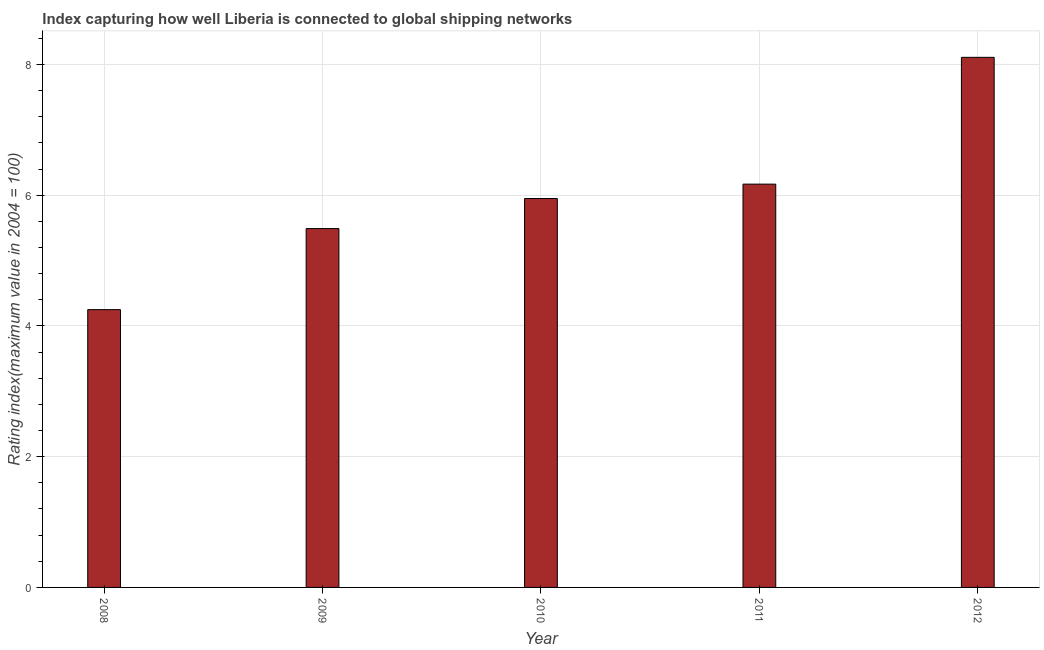Does the graph contain any zero values?
Make the answer very short. No. What is the title of the graph?
Provide a succinct answer. Index capturing how well Liberia is connected to global shipping networks. What is the label or title of the Y-axis?
Offer a very short reply. Rating index(maximum value in 2004 = 100). What is the liner shipping connectivity index in 2011?
Provide a succinct answer. 6.17. Across all years, what is the maximum liner shipping connectivity index?
Your answer should be very brief. 8.11. Across all years, what is the minimum liner shipping connectivity index?
Your answer should be compact. 4.25. In which year was the liner shipping connectivity index minimum?
Your answer should be very brief. 2008. What is the sum of the liner shipping connectivity index?
Give a very brief answer. 29.97. What is the difference between the liner shipping connectivity index in 2010 and 2012?
Provide a short and direct response. -2.16. What is the average liner shipping connectivity index per year?
Offer a very short reply. 5.99. What is the median liner shipping connectivity index?
Give a very brief answer. 5.95. Do a majority of the years between 2009 and 2011 (inclusive) have liner shipping connectivity index greater than 1.6 ?
Provide a succinct answer. Yes. What is the ratio of the liner shipping connectivity index in 2009 to that in 2011?
Make the answer very short. 0.89. Is the liner shipping connectivity index in 2010 less than that in 2011?
Your answer should be compact. Yes. Is the difference between the liner shipping connectivity index in 2008 and 2010 greater than the difference between any two years?
Your response must be concise. No. What is the difference between the highest and the second highest liner shipping connectivity index?
Provide a short and direct response. 1.94. Is the sum of the liner shipping connectivity index in 2008 and 2010 greater than the maximum liner shipping connectivity index across all years?
Offer a very short reply. Yes. What is the difference between the highest and the lowest liner shipping connectivity index?
Give a very brief answer. 3.86. In how many years, is the liner shipping connectivity index greater than the average liner shipping connectivity index taken over all years?
Give a very brief answer. 2. How many years are there in the graph?
Your answer should be compact. 5. What is the Rating index(maximum value in 2004 = 100) of 2008?
Your answer should be compact. 4.25. What is the Rating index(maximum value in 2004 = 100) in 2009?
Give a very brief answer. 5.49. What is the Rating index(maximum value in 2004 = 100) in 2010?
Your response must be concise. 5.95. What is the Rating index(maximum value in 2004 = 100) in 2011?
Offer a terse response. 6.17. What is the Rating index(maximum value in 2004 = 100) of 2012?
Keep it short and to the point. 8.11. What is the difference between the Rating index(maximum value in 2004 = 100) in 2008 and 2009?
Offer a terse response. -1.24. What is the difference between the Rating index(maximum value in 2004 = 100) in 2008 and 2011?
Offer a terse response. -1.92. What is the difference between the Rating index(maximum value in 2004 = 100) in 2008 and 2012?
Ensure brevity in your answer.  -3.86. What is the difference between the Rating index(maximum value in 2004 = 100) in 2009 and 2010?
Your response must be concise. -0.46. What is the difference between the Rating index(maximum value in 2004 = 100) in 2009 and 2011?
Ensure brevity in your answer.  -0.68. What is the difference between the Rating index(maximum value in 2004 = 100) in 2009 and 2012?
Your answer should be compact. -2.62. What is the difference between the Rating index(maximum value in 2004 = 100) in 2010 and 2011?
Your answer should be very brief. -0.22. What is the difference between the Rating index(maximum value in 2004 = 100) in 2010 and 2012?
Your answer should be very brief. -2.16. What is the difference between the Rating index(maximum value in 2004 = 100) in 2011 and 2012?
Your answer should be compact. -1.94. What is the ratio of the Rating index(maximum value in 2004 = 100) in 2008 to that in 2009?
Provide a short and direct response. 0.77. What is the ratio of the Rating index(maximum value in 2004 = 100) in 2008 to that in 2010?
Ensure brevity in your answer.  0.71. What is the ratio of the Rating index(maximum value in 2004 = 100) in 2008 to that in 2011?
Keep it short and to the point. 0.69. What is the ratio of the Rating index(maximum value in 2004 = 100) in 2008 to that in 2012?
Keep it short and to the point. 0.52. What is the ratio of the Rating index(maximum value in 2004 = 100) in 2009 to that in 2010?
Keep it short and to the point. 0.92. What is the ratio of the Rating index(maximum value in 2004 = 100) in 2009 to that in 2011?
Your answer should be very brief. 0.89. What is the ratio of the Rating index(maximum value in 2004 = 100) in 2009 to that in 2012?
Your response must be concise. 0.68. What is the ratio of the Rating index(maximum value in 2004 = 100) in 2010 to that in 2012?
Keep it short and to the point. 0.73. What is the ratio of the Rating index(maximum value in 2004 = 100) in 2011 to that in 2012?
Offer a very short reply. 0.76. 